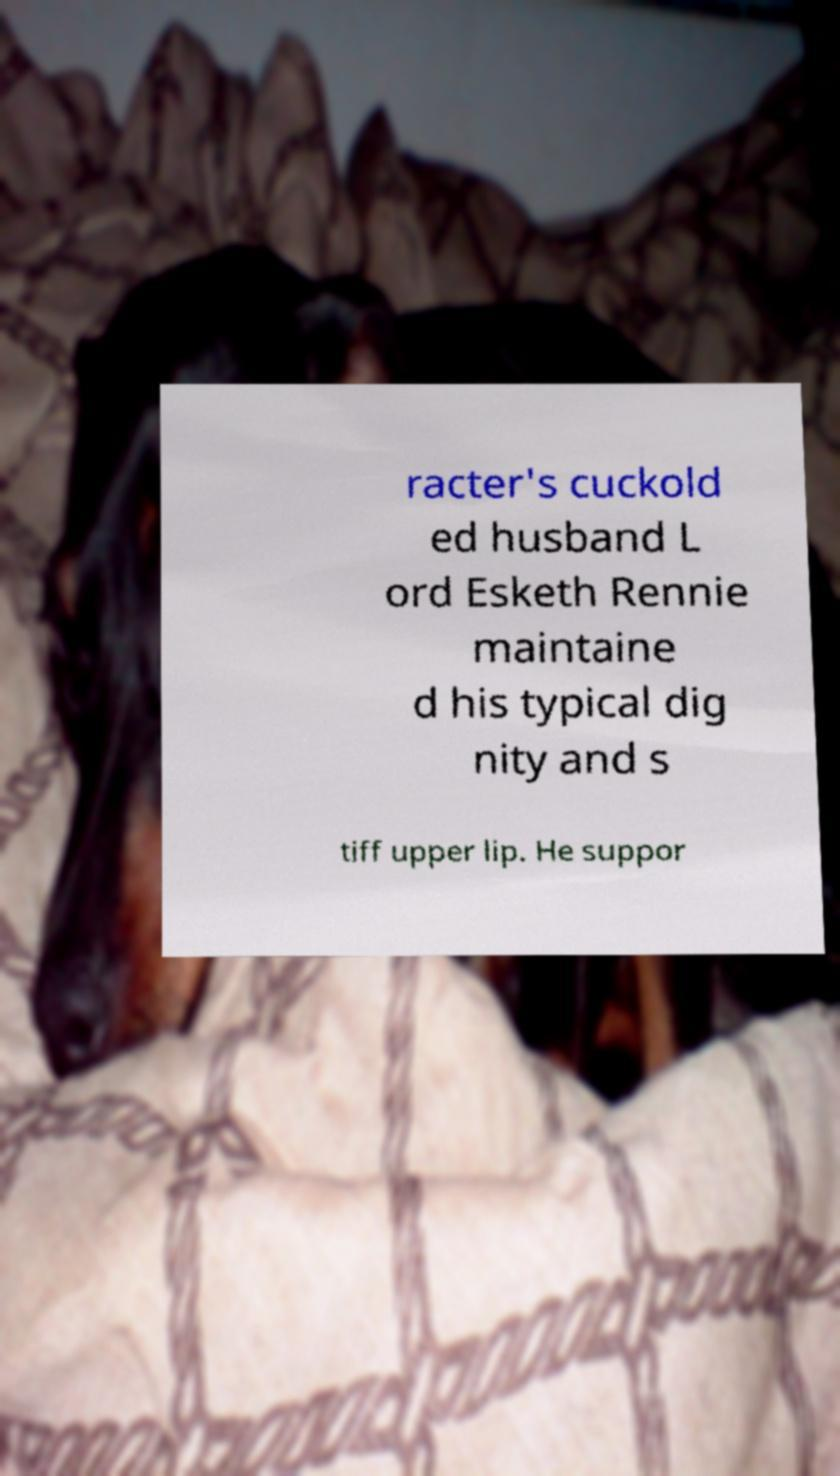Could you extract and type out the text from this image? racter's cuckold ed husband L ord Esketh Rennie maintaine d his typical dig nity and s tiff upper lip. He suppor 